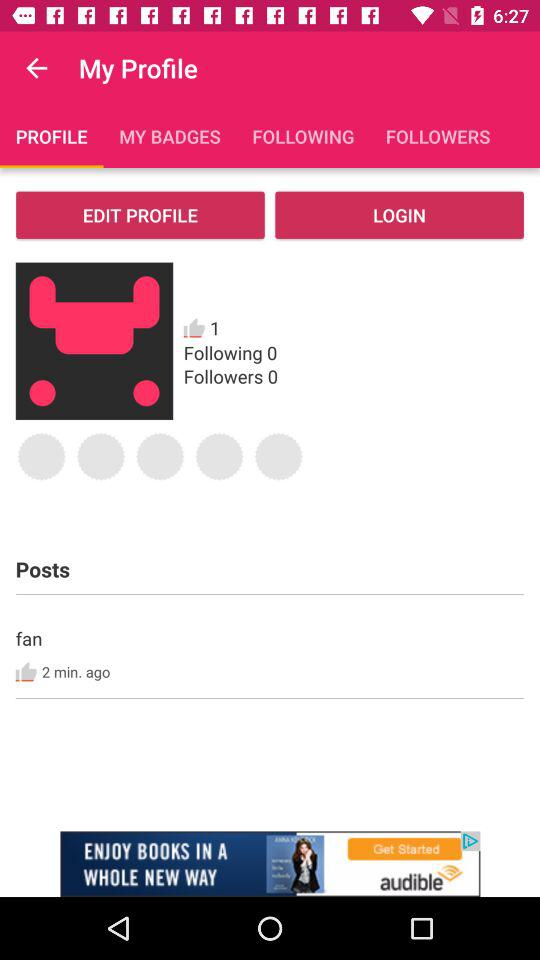What is the selected tab? The selected tab is "PROFILE". 